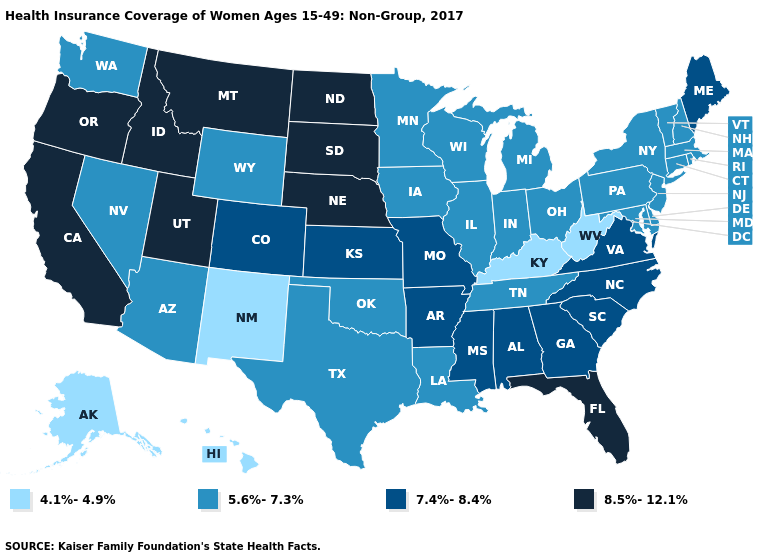Is the legend a continuous bar?
Short answer required. No. Does Hawaii have the lowest value in the USA?
Quick response, please. Yes. Which states have the highest value in the USA?
Write a very short answer. California, Florida, Idaho, Montana, Nebraska, North Dakota, Oregon, South Dakota, Utah. What is the value of Connecticut?
Write a very short answer. 5.6%-7.3%. What is the lowest value in states that border Alabama?
Be succinct. 5.6%-7.3%. What is the value of Wyoming?
Quick response, please. 5.6%-7.3%. Name the states that have a value in the range 7.4%-8.4%?
Concise answer only. Alabama, Arkansas, Colorado, Georgia, Kansas, Maine, Mississippi, Missouri, North Carolina, South Carolina, Virginia. What is the value of Florida?
Be succinct. 8.5%-12.1%. What is the highest value in the USA?
Concise answer only. 8.5%-12.1%. What is the value of North Carolina?
Give a very brief answer. 7.4%-8.4%. Name the states that have a value in the range 8.5%-12.1%?
Quick response, please. California, Florida, Idaho, Montana, Nebraska, North Dakota, Oregon, South Dakota, Utah. What is the value of Nebraska?
Keep it brief. 8.5%-12.1%. What is the highest value in states that border Minnesota?
Keep it brief. 8.5%-12.1%. What is the lowest value in states that border New Hampshire?
Give a very brief answer. 5.6%-7.3%. Among the states that border Colorado , which have the lowest value?
Quick response, please. New Mexico. 